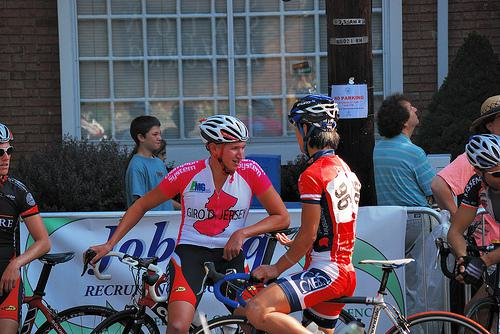Can you tell me about the jerseys the cyclists are wearing? The cyclists are wearing jerseys that are likely team uniforms, signifying their affiliation with specific teams or sponsors. The colors and patterns differ, indicating different teams or sponsorship deals. Such uniforms are not just for identification but are also designed for aerodynamics and comfort during races. 